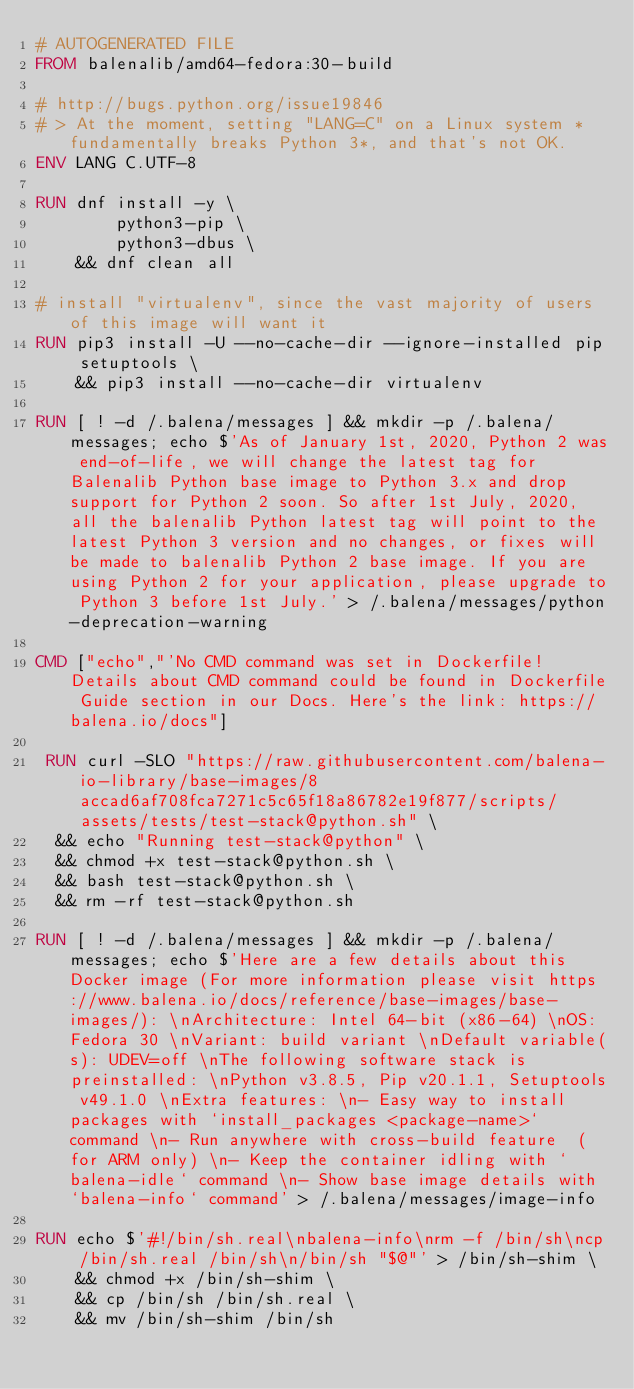Convert code to text. <code><loc_0><loc_0><loc_500><loc_500><_Dockerfile_># AUTOGENERATED FILE
FROM balenalib/amd64-fedora:30-build

# http://bugs.python.org/issue19846
# > At the moment, setting "LANG=C" on a Linux system *fundamentally breaks Python 3*, and that's not OK.
ENV LANG C.UTF-8

RUN dnf install -y \
		python3-pip \
		python3-dbus \
	&& dnf clean all

# install "virtualenv", since the vast majority of users of this image will want it
RUN pip3 install -U --no-cache-dir --ignore-installed pip setuptools \
	&& pip3 install --no-cache-dir virtualenv

RUN [ ! -d /.balena/messages ] && mkdir -p /.balena/messages; echo $'As of January 1st, 2020, Python 2 was end-of-life, we will change the latest tag for Balenalib Python base image to Python 3.x and drop support for Python 2 soon. So after 1st July, 2020, all the balenalib Python latest tag will point to the latest Python 3 version and no changes, or fixes will be made to balenalib Python 2 base image. If you are using Python 2 for your application, please upgrade to Python 3 before 1st July.' > /.balena/messages/python-deprecation-warning

CMD ["echo","'No CMD command was set in Dockerfile! Details about CMD command could be found in Dockerfile Guide section in our Docs. Here's the link: https://balena.io/docs"]

 RUN curl -SLO "https://raw.githubusercontent.com/balena-io-library/base-images/8accad6af708fca7271c5c65f18a86782e19f877/scripts/assets/tests/test-stack@python.sh" \
  && echo "Running test-stack@python" \
  && chmod +x test-stack@python.sh \
  && bash test-stack@python.sh \
  && rm -rf test-stack@python.sh 

RUN [ ! -d /.balena/messages ] && mkdir -p /.balena/messages; echo $'Here are a few details about this Docker image (For more information please visit https://www.balena.io/docs/reference/base-images/base-images/): \nArchitecture: Intel 64-bit (x86-64) \nOS: Fedora 30 \nVariant: build variant \nDefault variable(s): UDEV=off \nThe following software stack is preinstalled: \nPython v3.8.5, Pip v20.1.1, Setuptools v49.1.0 \nExtra features: \n- Easy way to install packages with `install_packages <package-name>` command \n- Run anywhere with cross-build feature  (for ARM only) \n- Keep the container idling with `balena-idle` command \n- Show base image details with `balena-info` command' > /.balena/messages/image-info

RUN echo $'#!/bin/sh.real\nbalena-info\nrm -f /bin/sh\ncp /bin/sh.real /bin/sh\n/bin/sh "$@"' > /bin/sh-shim \
	&& chmod +x /bin/sh-shim \
	&& cp /bin/sh /bin/sh.real \
	&& mv /bin/sh-shim /bin/sh</code> 